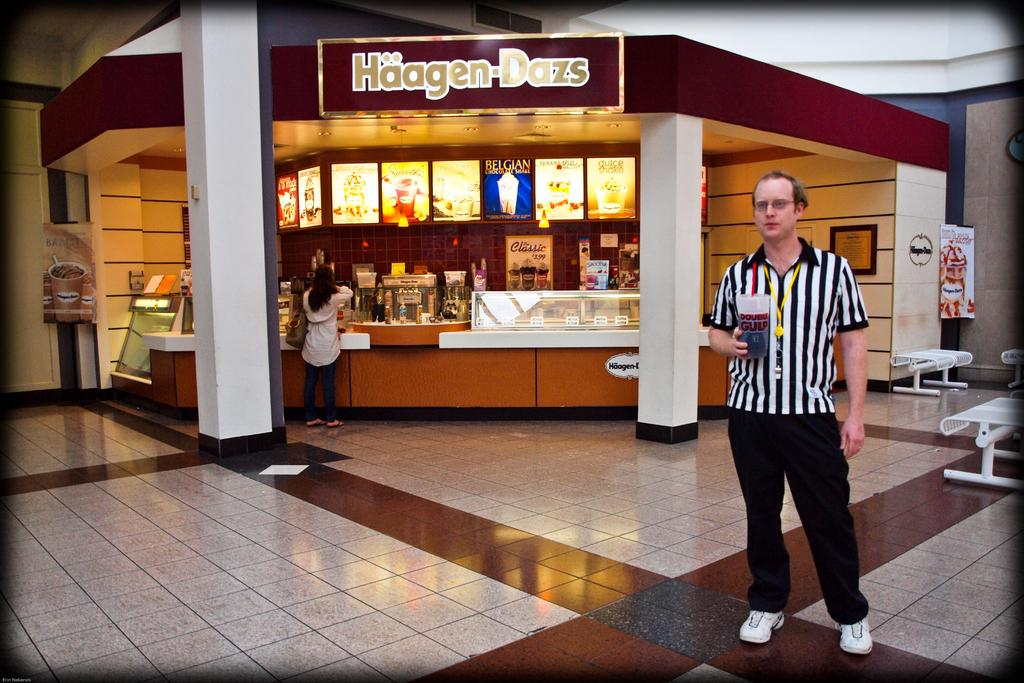What is the main subject in the foreground of the image? There is a man standing on the ground in the image. Can you describe the background of the image? In the background of the image, there is a woman, pillars, a wall, posters, and some objects. What type of structures can be seen in the background? Pillars and a wall are visible in the background of the image. What else is present in the background of the image? There are posters and some objects in the background of the image. What type of wood can be seen in the image? There is no wood present in the image. Are there any fairies visible in the image? There are no fairies present in the image. 